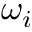<formula> <loc_0><loc_0><loc_500><loc_500>\omega _ { i }</formula> 